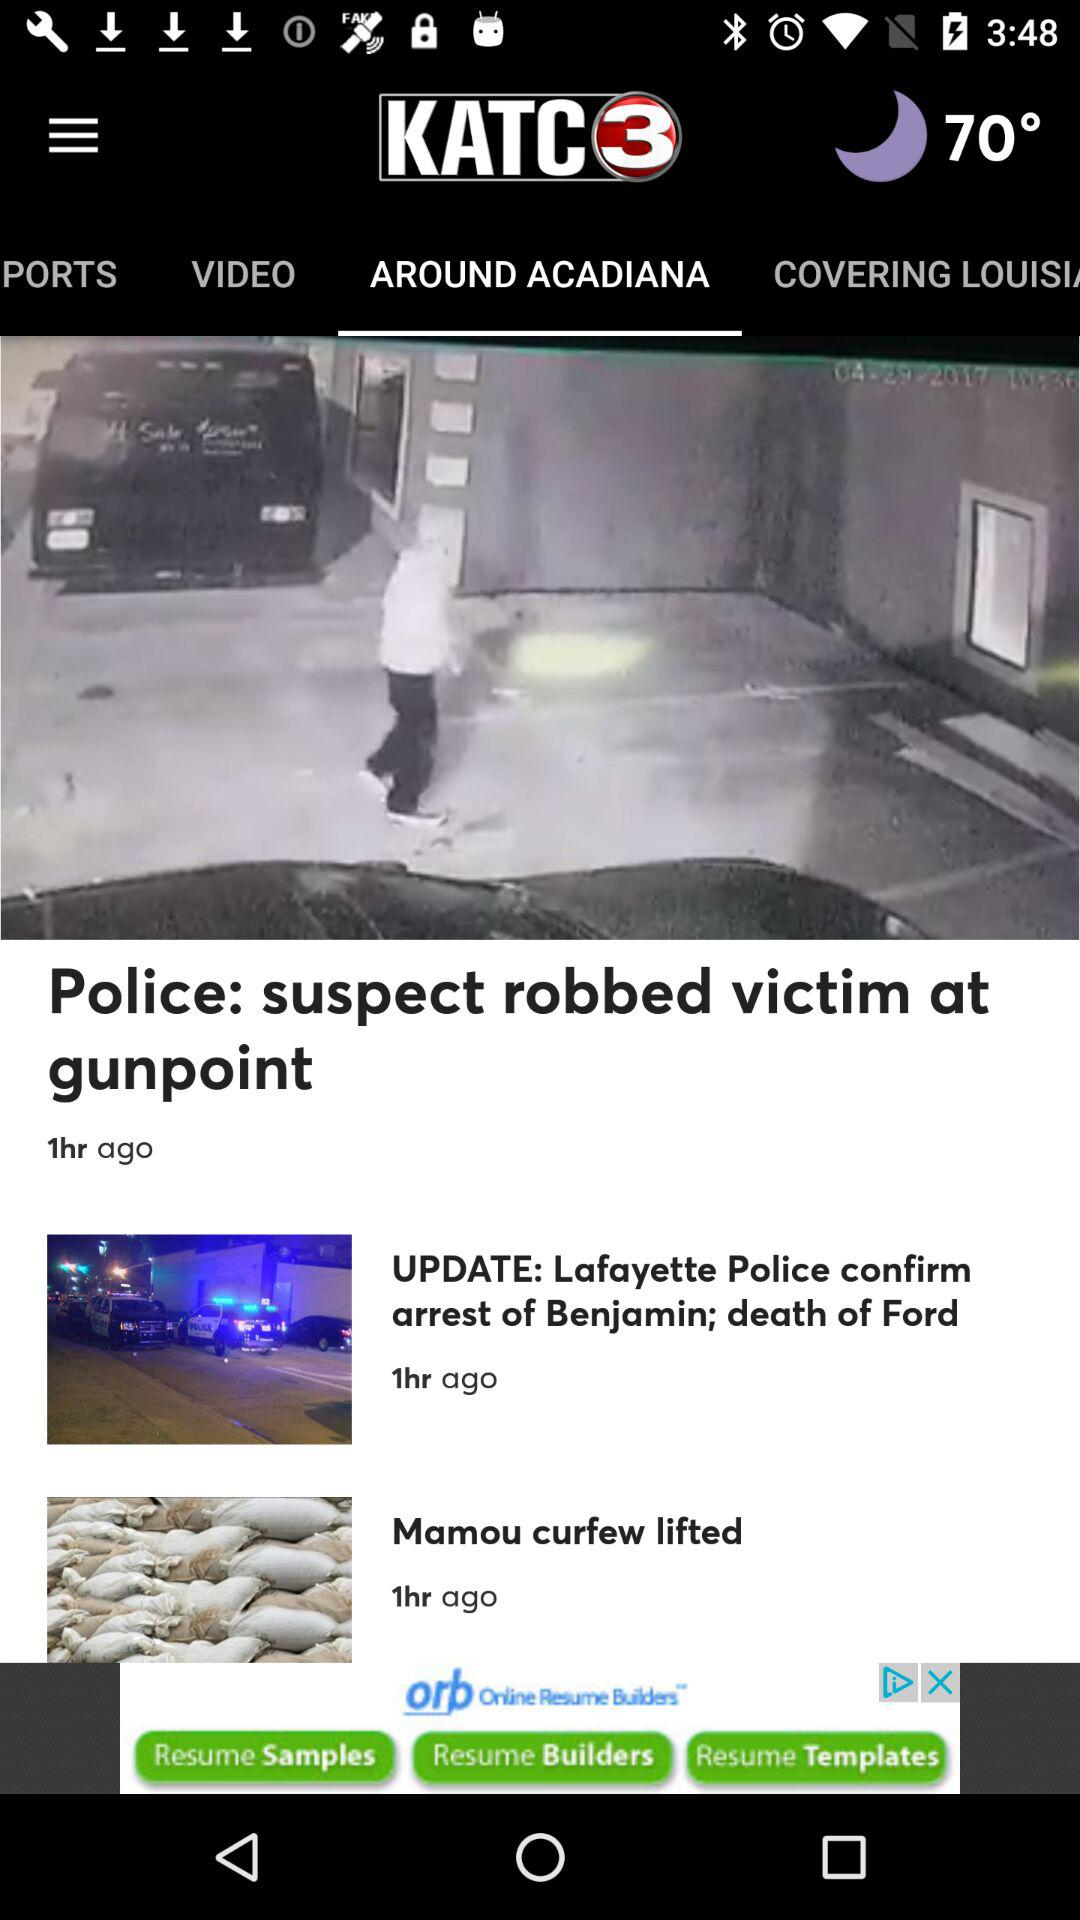What tab am I on? You are on the "AROUND ACADIANA" tab. 